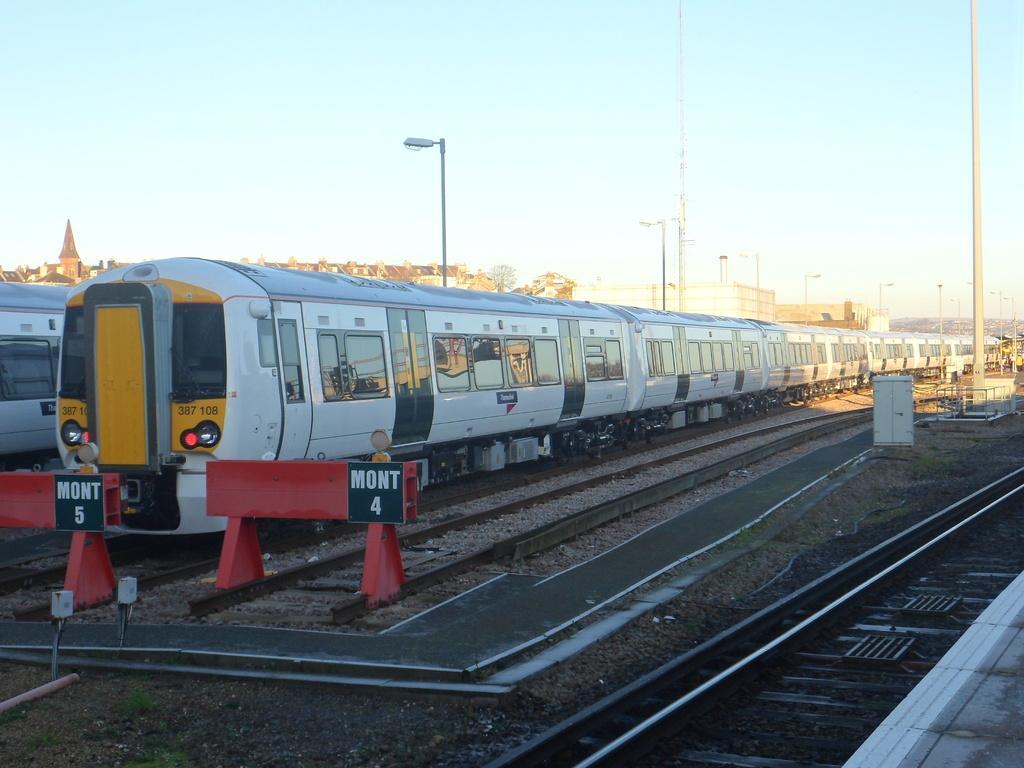How would you summarize this image in a sentence or two? In this image there are train tracks, on that track there are trains, beside the train there are poles, in the background there are houses and there is a sky. 